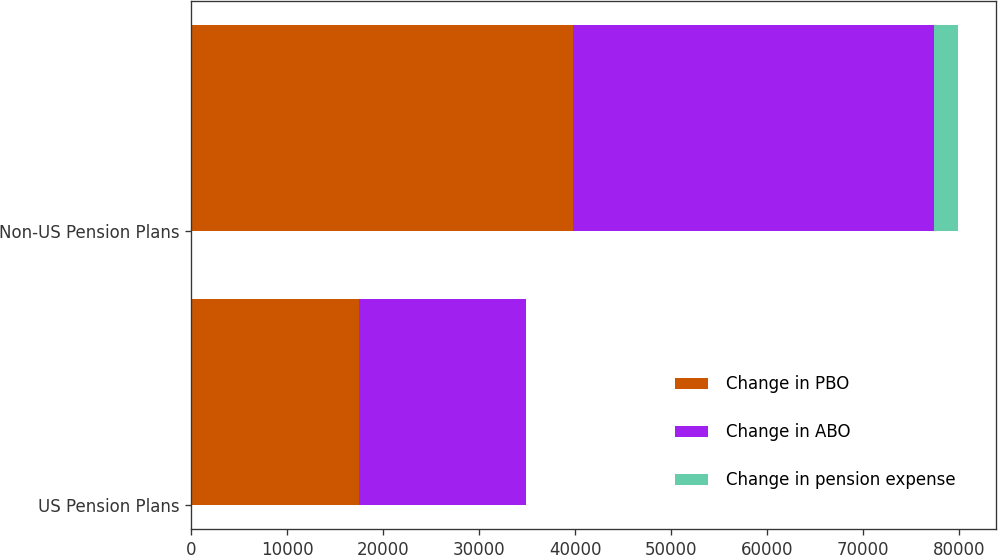<chart> <loc_0><loc_0><loc_500><loc_500><stacked_bar_chart><ecel><fcel>US Pension Plans<fcel>Non-US Pension Plans<nl><fcel>Change in PBO<fcel>17519<fcel>39727<nl><fcel>Change in ABO<fcel>17359<fcel>37661<nl><fcel>Change in pension expense<fcel>5<fcel>2478<nl></chart> 